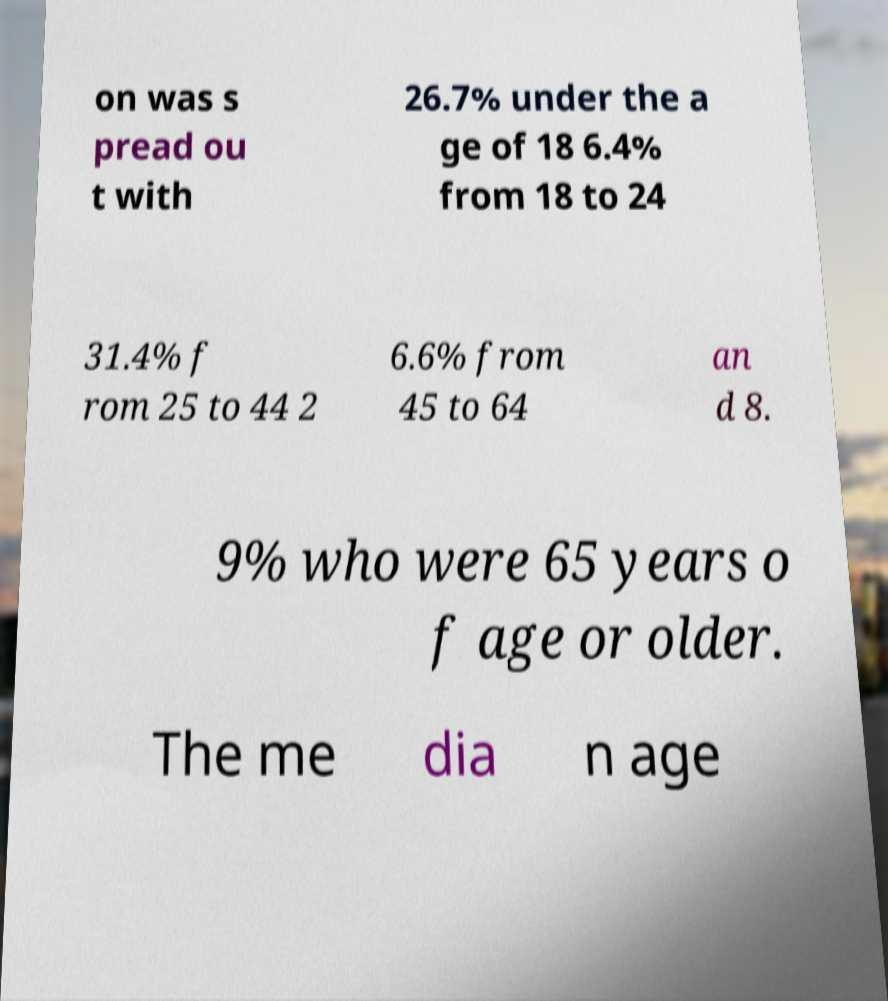Please identify and transcribe the text found in this image. on was s pread ou t with 26.7% under the a ge of 18 6.4% from 18 to 24 31.4% f rom 25 to 44 2 6.6% from 45 to 64 an d 8. 9% who were 65 years o f age or older. The me dia n age 